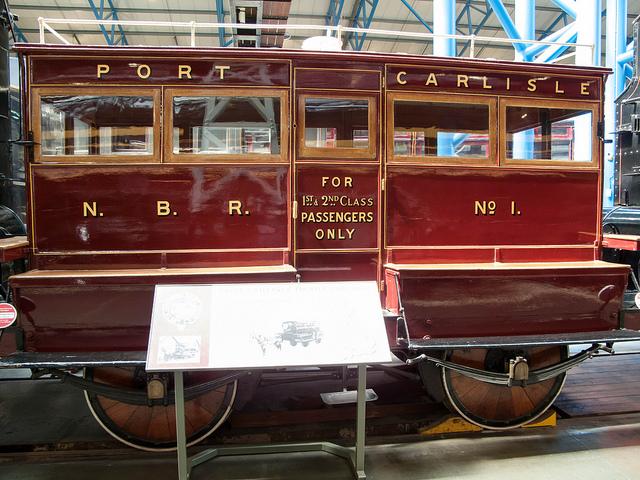What color is the train car?
Quick response, please. Red. Could you ride this train car today?
Quick response, please. No. Is this an antique?
Keep it brief. Yes. 